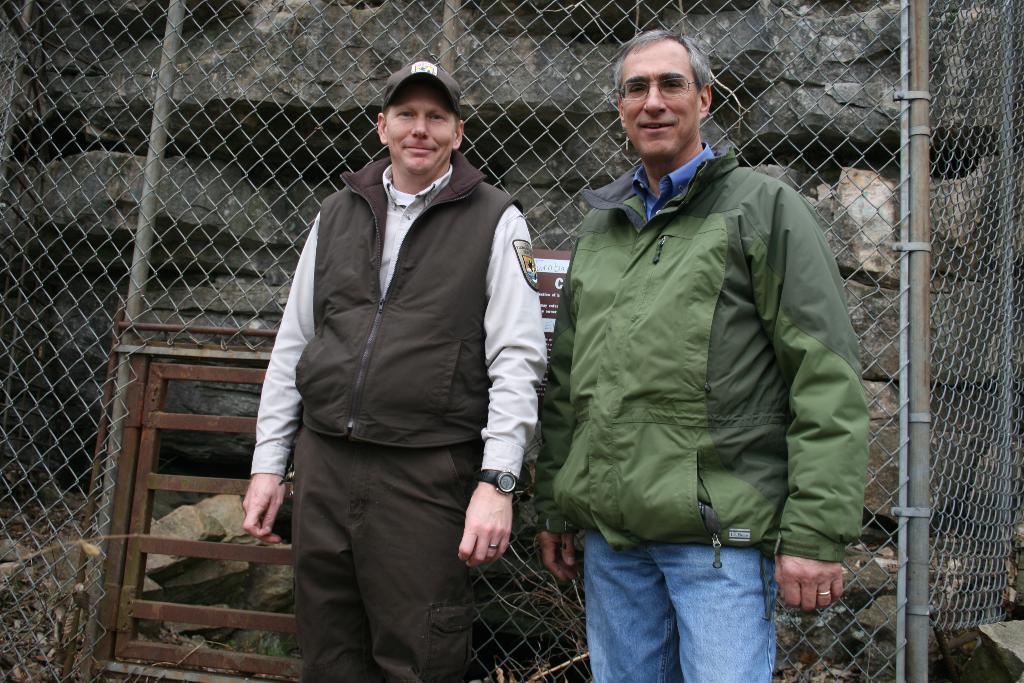Can you describe this image briefly? In this picture I see 2 men in front and I see that they're standing and both of them are smiling and in the background I see the fencing and the rocks. 